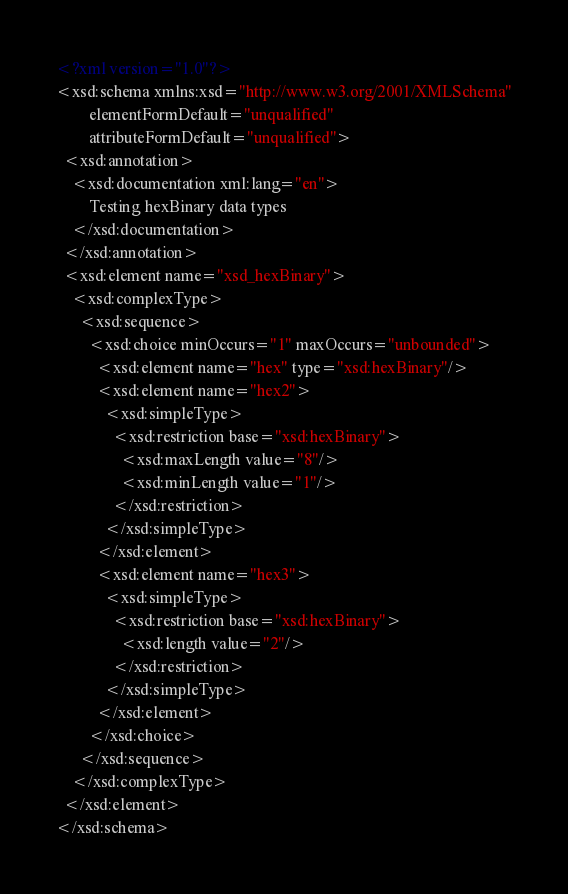Convert code to text. <code><loc_0><loc_0><loc_500><loc_500><_XML_><?xml version="1.0"?>
<xsd:schema xmlns:xsd="http://www.w3.org/2001/XMLSchema"
	    elementFormDefault="unqualified"
	    attributeFormDefault="unqualified">
  <xsd:annotation>
    <xsd:documentation xml:lang="en">
        Testing hexBinary data types
    </xsd:documentation>
  </xsd:annotation>
  <xsd:element name="xsd_hexBinary">
    <xsd:complexType>
      <xsd:sequence>
        <xsd:choice minOccurs="1" maxOccurs="unbounded">
          <xsd:element name="hex" type="xsd:hexBinary"/>
          <xsd:element name="hex2">
            <xsd:simpleType>
              <xsd:restriction base="xsd:hexBinary">
                <xsd:maxLength value="8"/>
                <xsd:minLength value="1"/>
              </xsd:restriction>
            </xsd:simpleType>
          </xsd:element>
          <xsd:element name="hex3">
            <xsd:simpleType>
              <xsd:restriction base="xsd:hexBinary">
                <xsd:length value="2"/>
              </xsd:restriction>
            </xsd:simpleType>
          </xsd:element>
        </xsd:choice>
      </xsd:sequence>
    </xsd:complexType>
  </xsd:element>
</xsd:schema>
</code> 